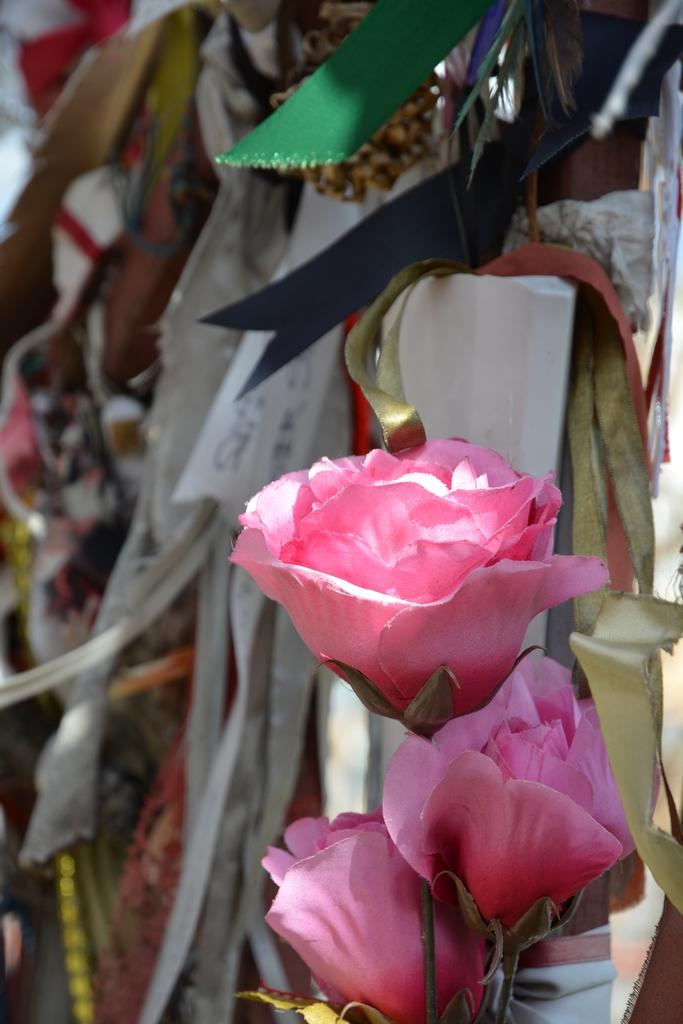What is located in the foreground of the image? There are flowers in the foreground of the image. What can be seen in the background of the image? There are objects in the background of the image. What type of crime is being committed in the image? There is no crime present in the image; it features flowers in the foreground and objects in the background. How many balls are visible in the image? There are no balls present in the image. 